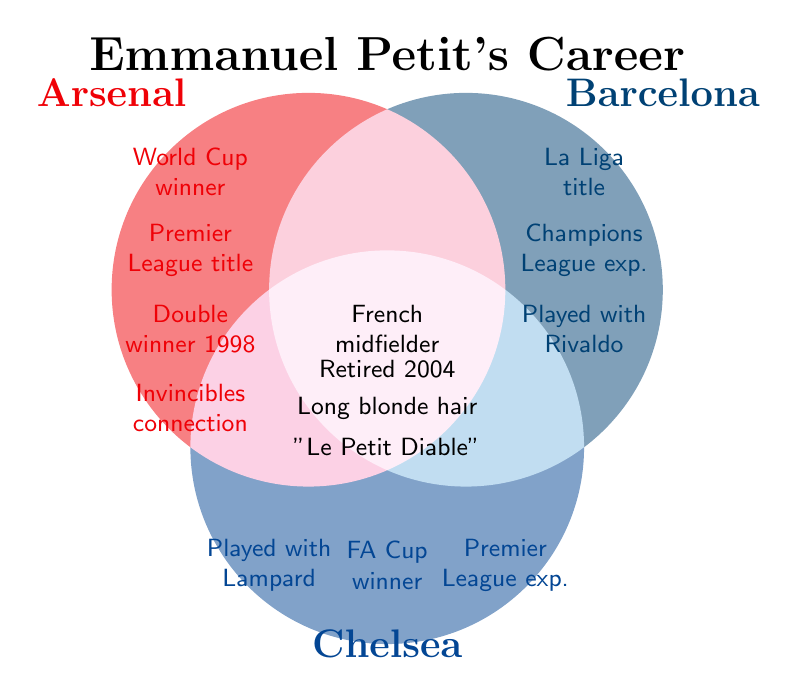Which teams did Emmanuel Petit play for during his career? Petit played for Arsenal, Barcelona, and Chelsea, as indicated by the Venn diagram.
Answer: Arsenal, Barcelona, Chelsea What achievements did Emmanuel Petit have with Arsenal? By looking at the Arsenal section of the Venn diagram, Petit won the World Cup, the Premier League title, and was part of the Double winner team of 1998. He also had a connection with the Invincibles era.
Answer: World Cup winner, Premier League title, Double winner 1998, Invincibles era connection Which team gave Emmanuel Petit the experience of playing with Frank Lampard? According to the diagram, the experience of playing with Frank Lampard falls under the Chelsea section.
Answer: Chelsea Which achievements are shared among all the teams Petit played for? The center of the Venn diagram shows the attributes that apply to his entire career. These include being a French midfielder, retiring in 2004, having long blonde hair, and his nickname "Le Petit Diable."
Answer: French midfielder, Retired 2004, Long blonde hair, "Le Petit Diable" Did Emmanuel Petit win a La Liga title during his career? The achievement of winning a La Liga title is listed under the Barcelona section of the Venn diagram.
Answer: Yes How many unique accolades are associated with Emmanuel Petit's career? By counting all unique accolades in the diagram, we have: World Cup winner, La Liga title, FA Cup winner, Premier League title, Champions League experience, Double winner 1998, Played with Rivaldo, Played with Frank Lampard, French midfielder, Retired in 2004, Long blonde hair, and "Le Petit Diable." This totals to 12 unique accolades.
Answer: 12 Which team did Emmanuel Petit play for when he won the FA Cup? The FA Cup winner accolade is listed under the Chelsea section in the Venn diagram.
Answer: Chelsea Which accolades did Petit achieve that are not shared with any other team? Each team's unique accolades not shared with any other team are indicated in their respective sections. For Arsenal, these are World Cup winner, Premier League title, Double winner 1998, and Invincibles connection. For Barcelona, these are La Liga title and Played with Rivaldo. For Chelsea, these are FA Cup winner and Played with Lampard.
Answer: Arsenal: World Cup winner, Premier League title, Double winner 1998, Invincibles connection; Barcelona: La Liga title, Played with Rivaldo; Chelsea: FA Cup winner, Played with Lampard What nickname is associated with Emmanuel Petit? The nickname "Le Petit Diable" is indicated in the section shared by all teams.
Answer: "Le Petit Diable" What physical attribute mentioned in the diagram is notable for Emmanuel Petit? The diagram mentions that Petit is known for his long blonde hair, which is listed in the section shared by all teams.
Answer: Long blonde hair 